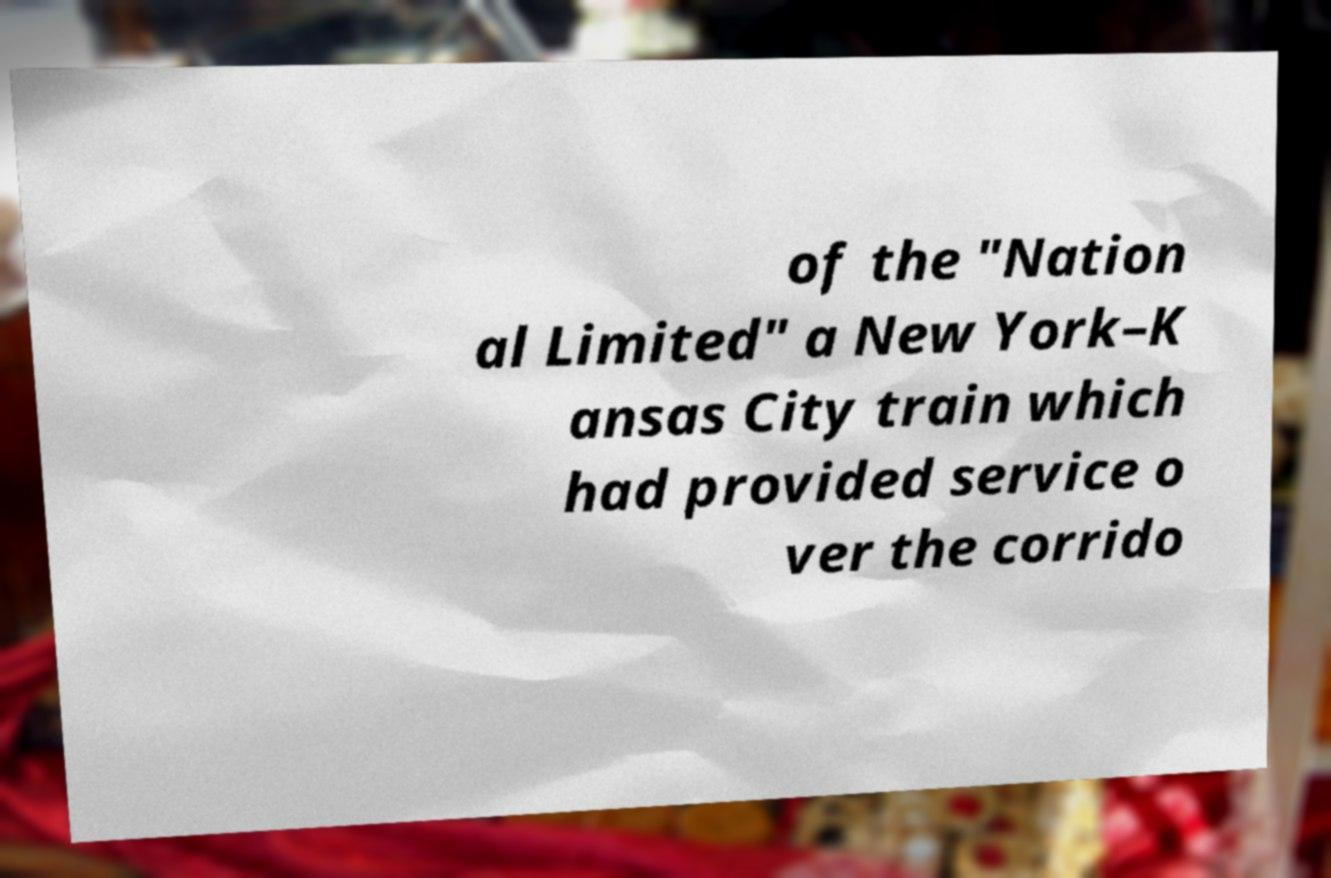Please identify and transcribe the text found in this image. of the "Nation al Limited" a New York–K ansas City train which had provided service o ver the corrido 